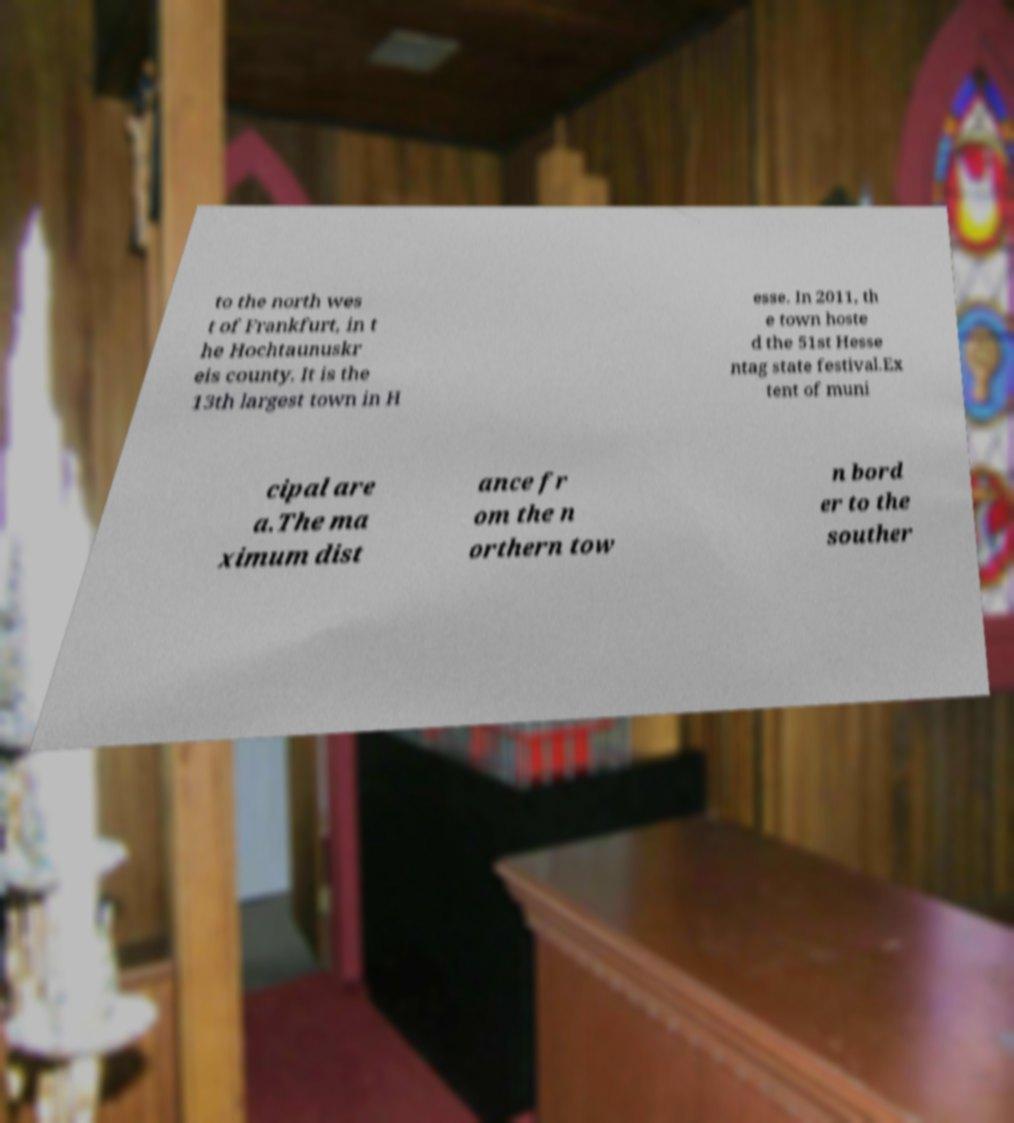I need the written content from this picture converted into text. Can you do that? to the north wes t of Frankfurt, in t he Hochtaunuskr eis county. It is the 13th largest town in H esse. In 2011, th e town hoste d the 51st Hesse ntag state festival.Ex tent of muni cipal are a.The ma ximum dist ance fr om the n orthern tow n bord er to the souther 